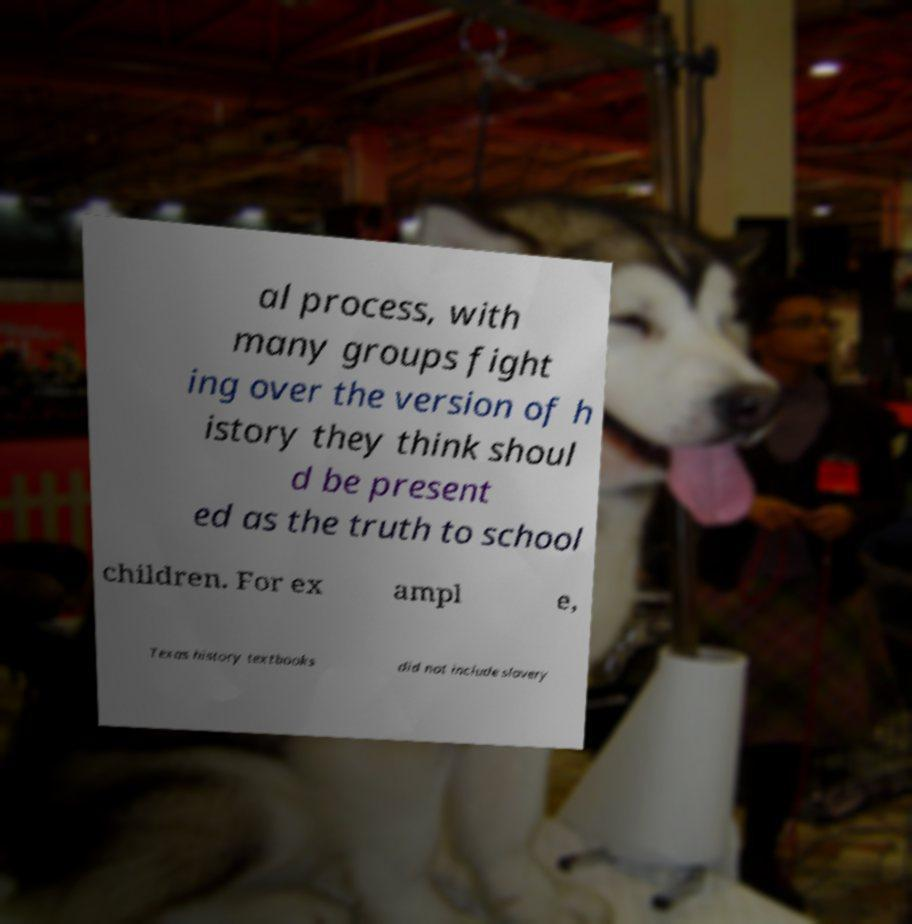What messages or text are displayed in this image? I need them in a readable, typed format. al process, with many groups fight ing over the version of h istory they think shoul d be present ed as the truth to school children. For ex ampl e, Texas history textbooks did not include slavery 